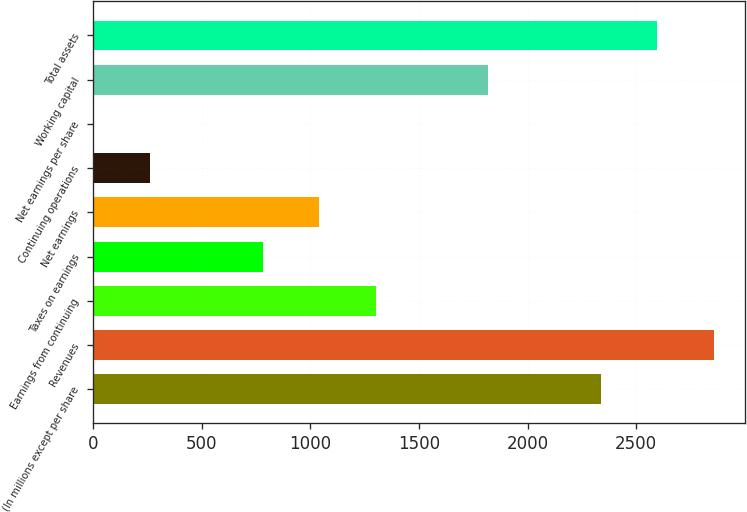<chart> <loc_0><loc_0><loc_500><loc_500><bar_chart><fcel>(In millions except per share<fcel>Revenues<fcel>Earnings from continuing<fcel>Taxes on earnings<fcel>Net earnings<fcel>Continuing operations<fcel>Net earnings per share<fcel>Working capital<fcel>Total assets<nl><fcel>2337.39<fcel>2856.05<fcel>1300.07<fcel>781.41<fcel>1040.74<fcel>262.75<fcel>3.42<fcel>1818.73<fcel>2596.72<nl></chart> 